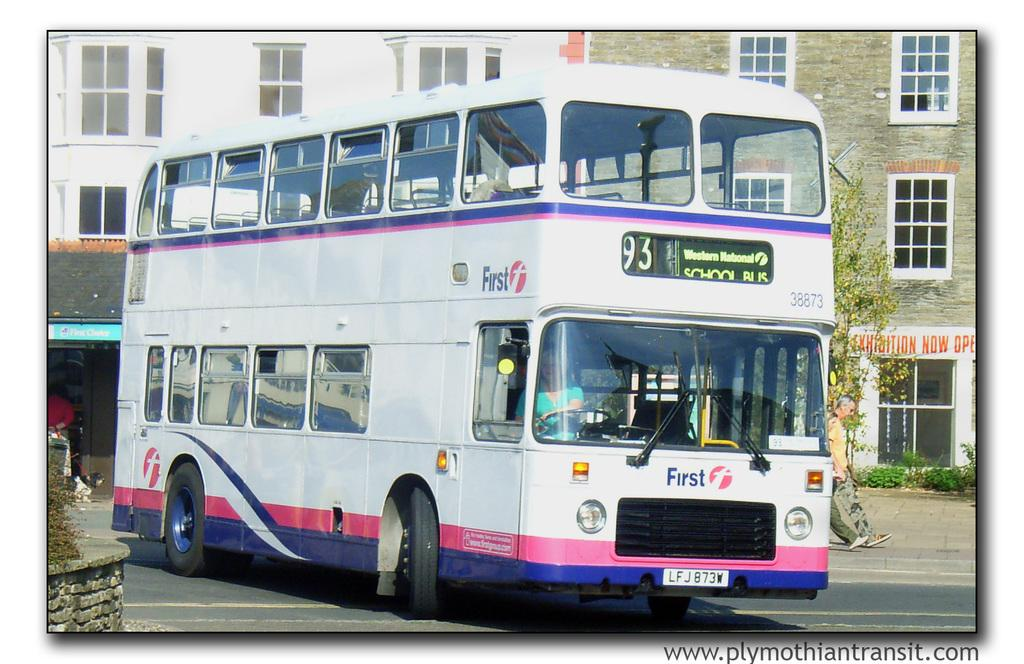What is the main subject of the image? The main subject of the image is a bus on the road. What are the people in the image doing? Two persons are walking on the road beside the bus. What can be seen in the background of the image? There are buildings visible at the back side of the image. How many cows can be seen grazing on the road in the image? There are no cows present in the image; it features a bus and two people walking on the road. What is the desire of the boys in the image? There are no boys present in the image, so it is not possible to determine their desires. 